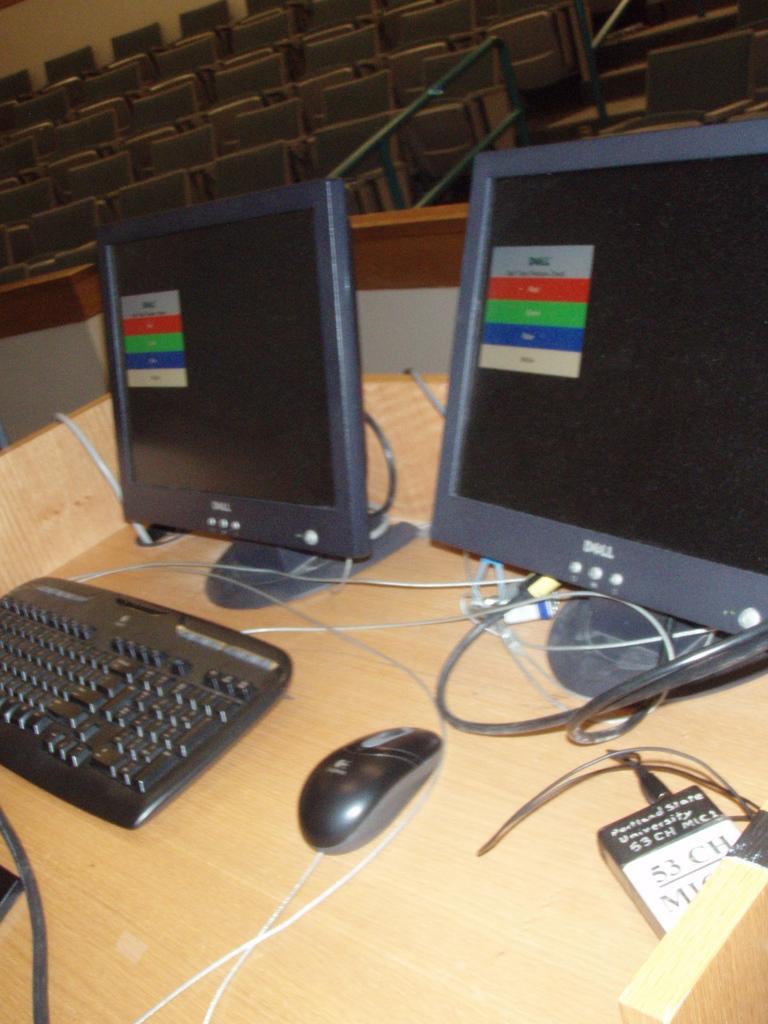What is the brand name of the monitors?
Provide a succinct answer. Dell. What channel is on the sign on the bottom right?
Ensure brevity in your answer.  53. 